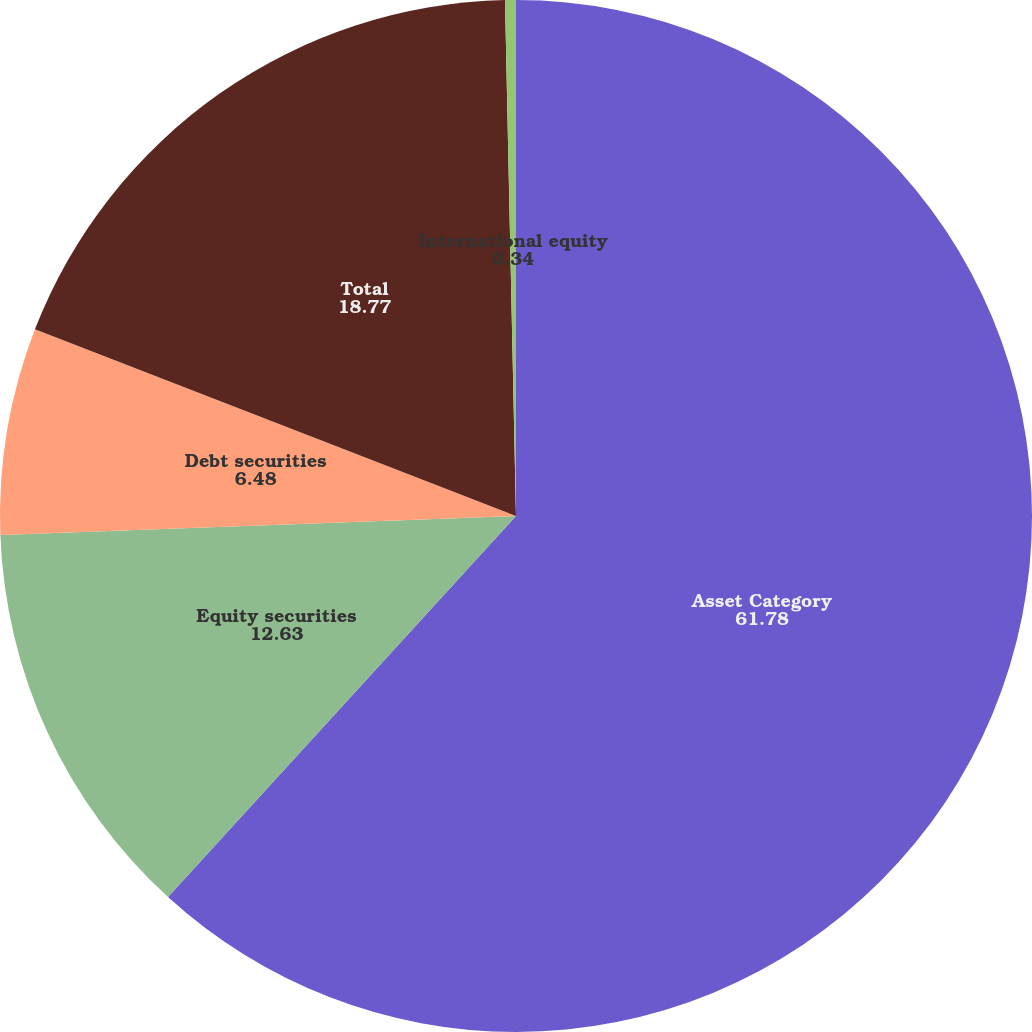Convert chart to OTSL. <chart><loc_0><loc_0><loc_500><loc_500><pie_chart><fcel>Asset Category<fcel>Equity securities<fcel>Debt securities<fcel>Total<fcel>International equity<nl><fcel>61.78%<fcel>12.63%<fcel>6.48%<fcel>18.77%<fcel>0.34%<nl></chart> 